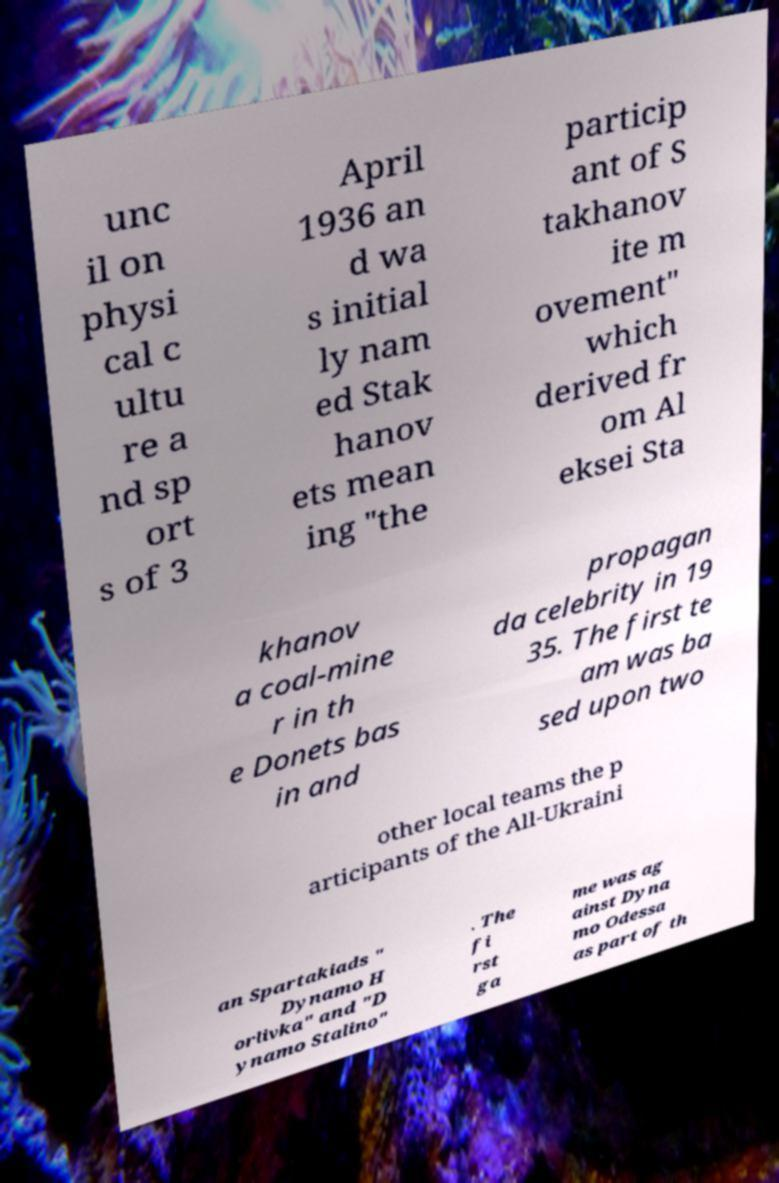Please identify and transcribe the text found in this image. unc il on physi cal c ultu re a nd sp ort s of 3 April 1936 an d wa s initial ly nam ed Stak hanov ets mean ing "the particip ant of S takhanov ite m ovement" which derived fr om Al eksei Sta khanov a coal-mine r in th e Donets bas in and propagan da celebrity in 19 35. The first te am was ba sed upon two other local teams the p articipants of the All-Ukraini an Spartakiads " Dynamo H orlivka" and "D ynamo Stalino" . The fi rst ga me was ag ainst Dyna mo Odessa as part of th 